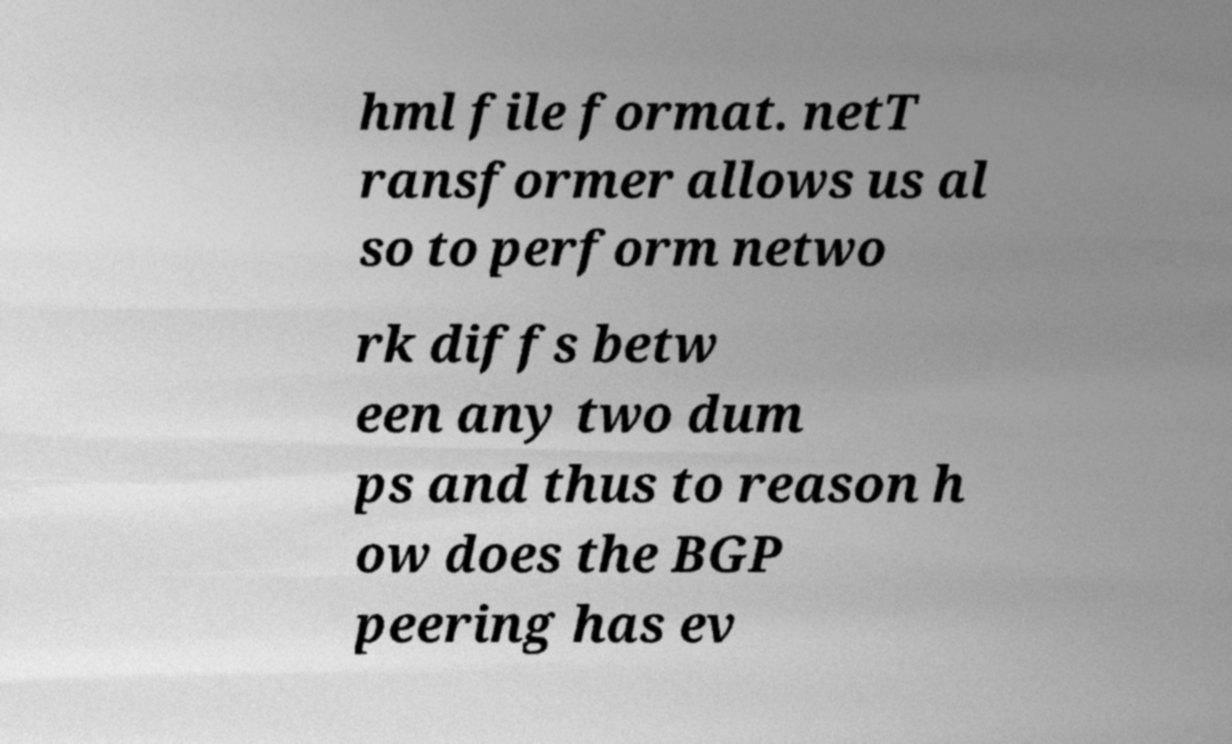I need the written content from this picture converted into text. Can you do that? hml file format. netT ransformer allows us al so to perform netwo rk diffs betw een any two dum ps and thus to reason h ow does the BGP peering has ev 